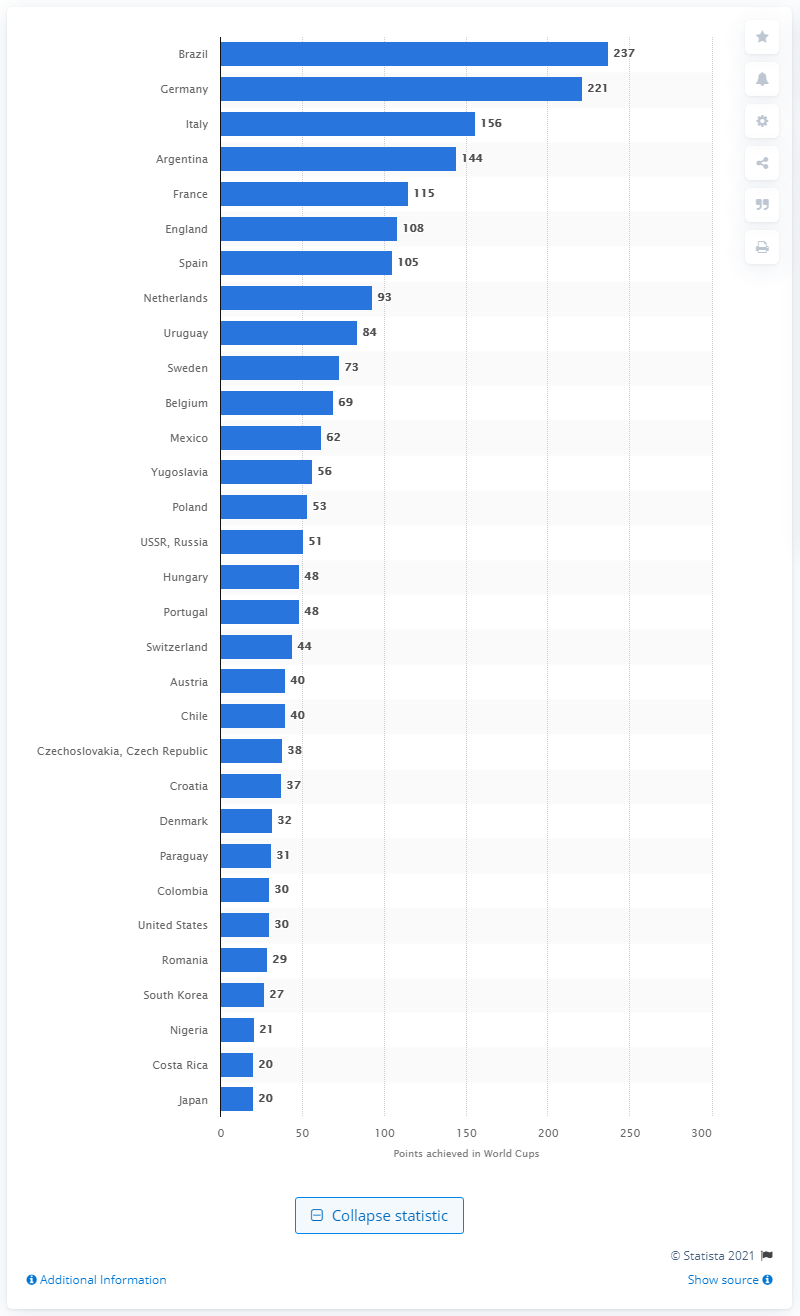Mention a couple of crucial points in this snapshot. As of today, the German national team has accumulated a total of 221 points. 